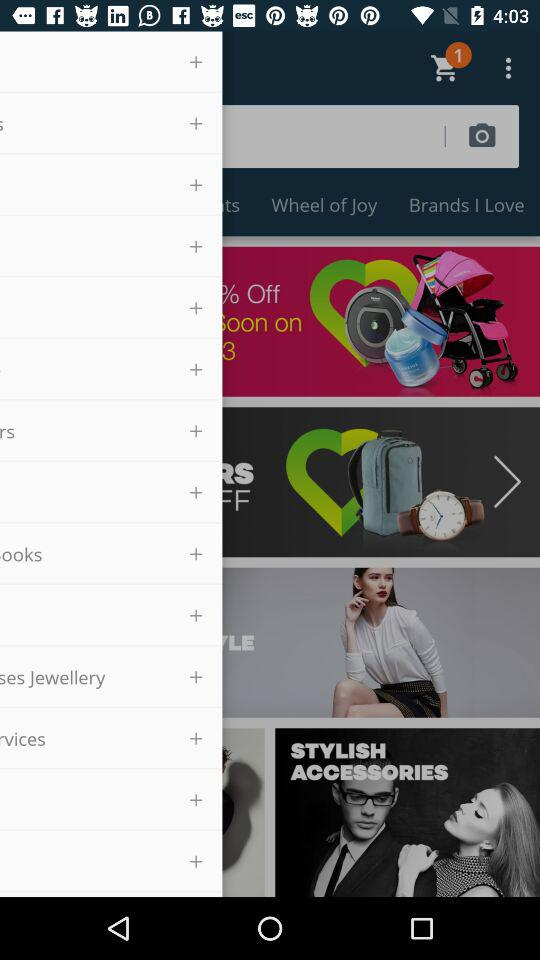How many items are there in the cart? There is 1 item in the cart. 